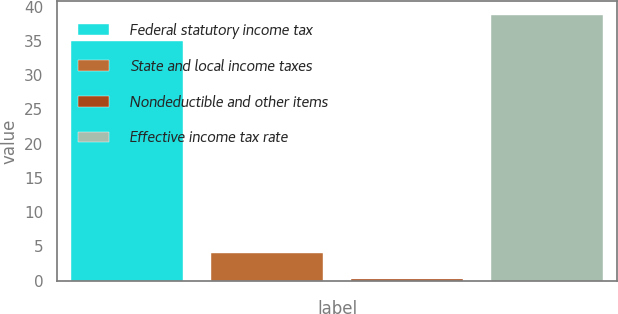Convert chart. <chart><loc_0><loc_0><loc_500><loc_500><bar_chart><fcel>Federal statutory income tax<fcel>State and local income taxes<fcel>Nondeductible and other items<fcel>Effective income tax rate<nl><fcel>35<fcel>4<fcel>0.2<fcel>38.8<nl></chart> 